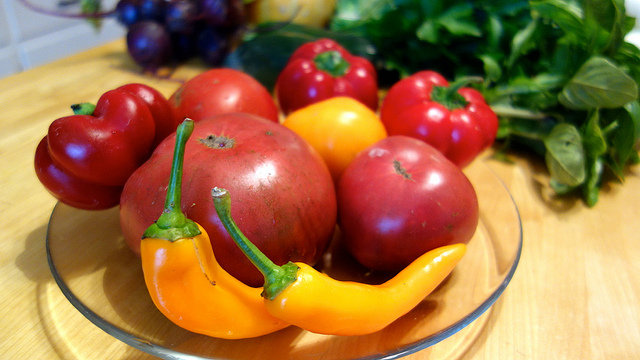Are these vegetables a good choice for a healthy diet? Absolutely! The vegetables shown are rich in vitamins, minerals, and antioxidants, making them an excellent choice for a healthy diet. They provide dietary fiber, which is beneficial for digestive health, and the colorful variety ensures a mix of different nutrients. 